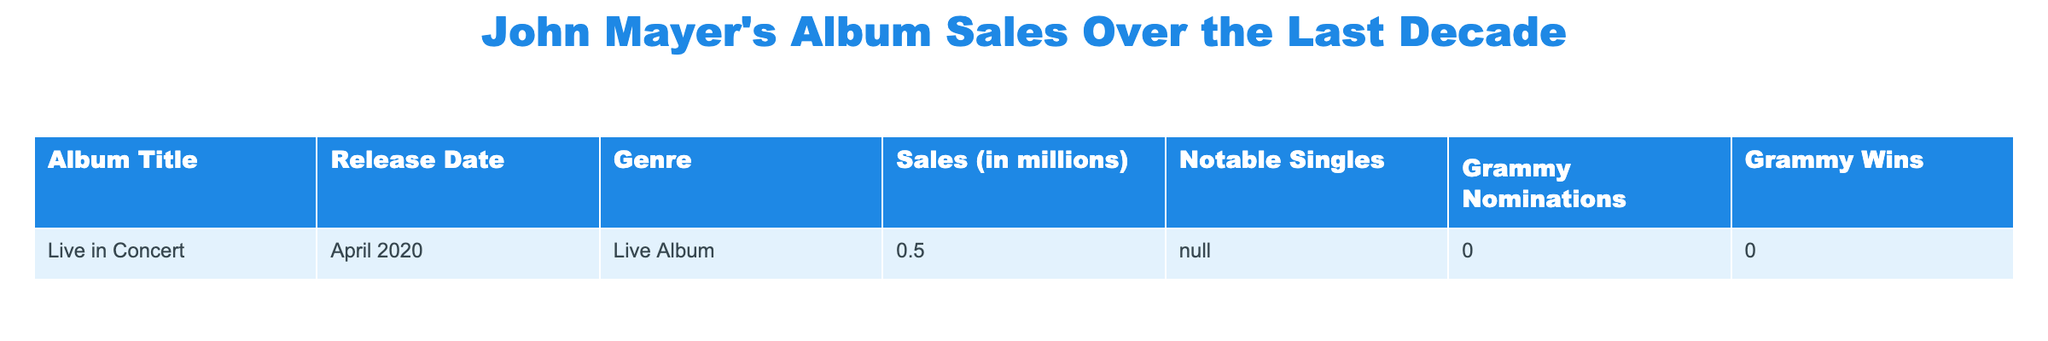What is the total sales figure for the album "Live in Concert"? The sales figure for "Live in Concert" is listed as 0.5 million. Since there is only one album in the table, the total sales are the same as the individual album sales.
Answer: 0.5 million How many Grammy nominations did "Live in Concert" receive? The table indicates that "Live in Concert" received 0 Grammy nominations. This value is directly taken from the table.
Answer: 0 Did "Live in Concert" win any Grammys? According to the table, "Live in Concert" won 0 Grammys. This fact is clearly stated in the table under Grammy Wins.
Answer: No What is the genre of the album "Live in Concert"? The genre listed for "Live in Concert" in the table is Live Album. This information can be found in the genre column corresponding to the album title.
Answer: Live Album Are there any notable singles from "Live in Concert"? The table shows "N/A" under notable singles for "Live in Concert". This means there are no notable singles mentioned.
Answer: No How does the sales figure for "Live in Concert" compare to other albums in the last decade? The table currently contains data for only one album, so it is not possible to compare its sales figure to any other album. Hence, no comparison can be made.
Answer: Not applicable What is the average sales figure if we consider multiple albums with the given data? Since "Live in Concert" is the only album listed, the average sales figure is the same as its sales figure which is 0.5 million. Average is calculated as total sales divided by the number of albums.
Answer: 0.5 million Which album has the highest number of Grammy wins in the table? The table only includes "Live in Concert", which has 0 Grammy wins. Therefore, there are no other albums to compare it to, making it the only album listed.
Answer: "Live in Concert" (0 wins) 